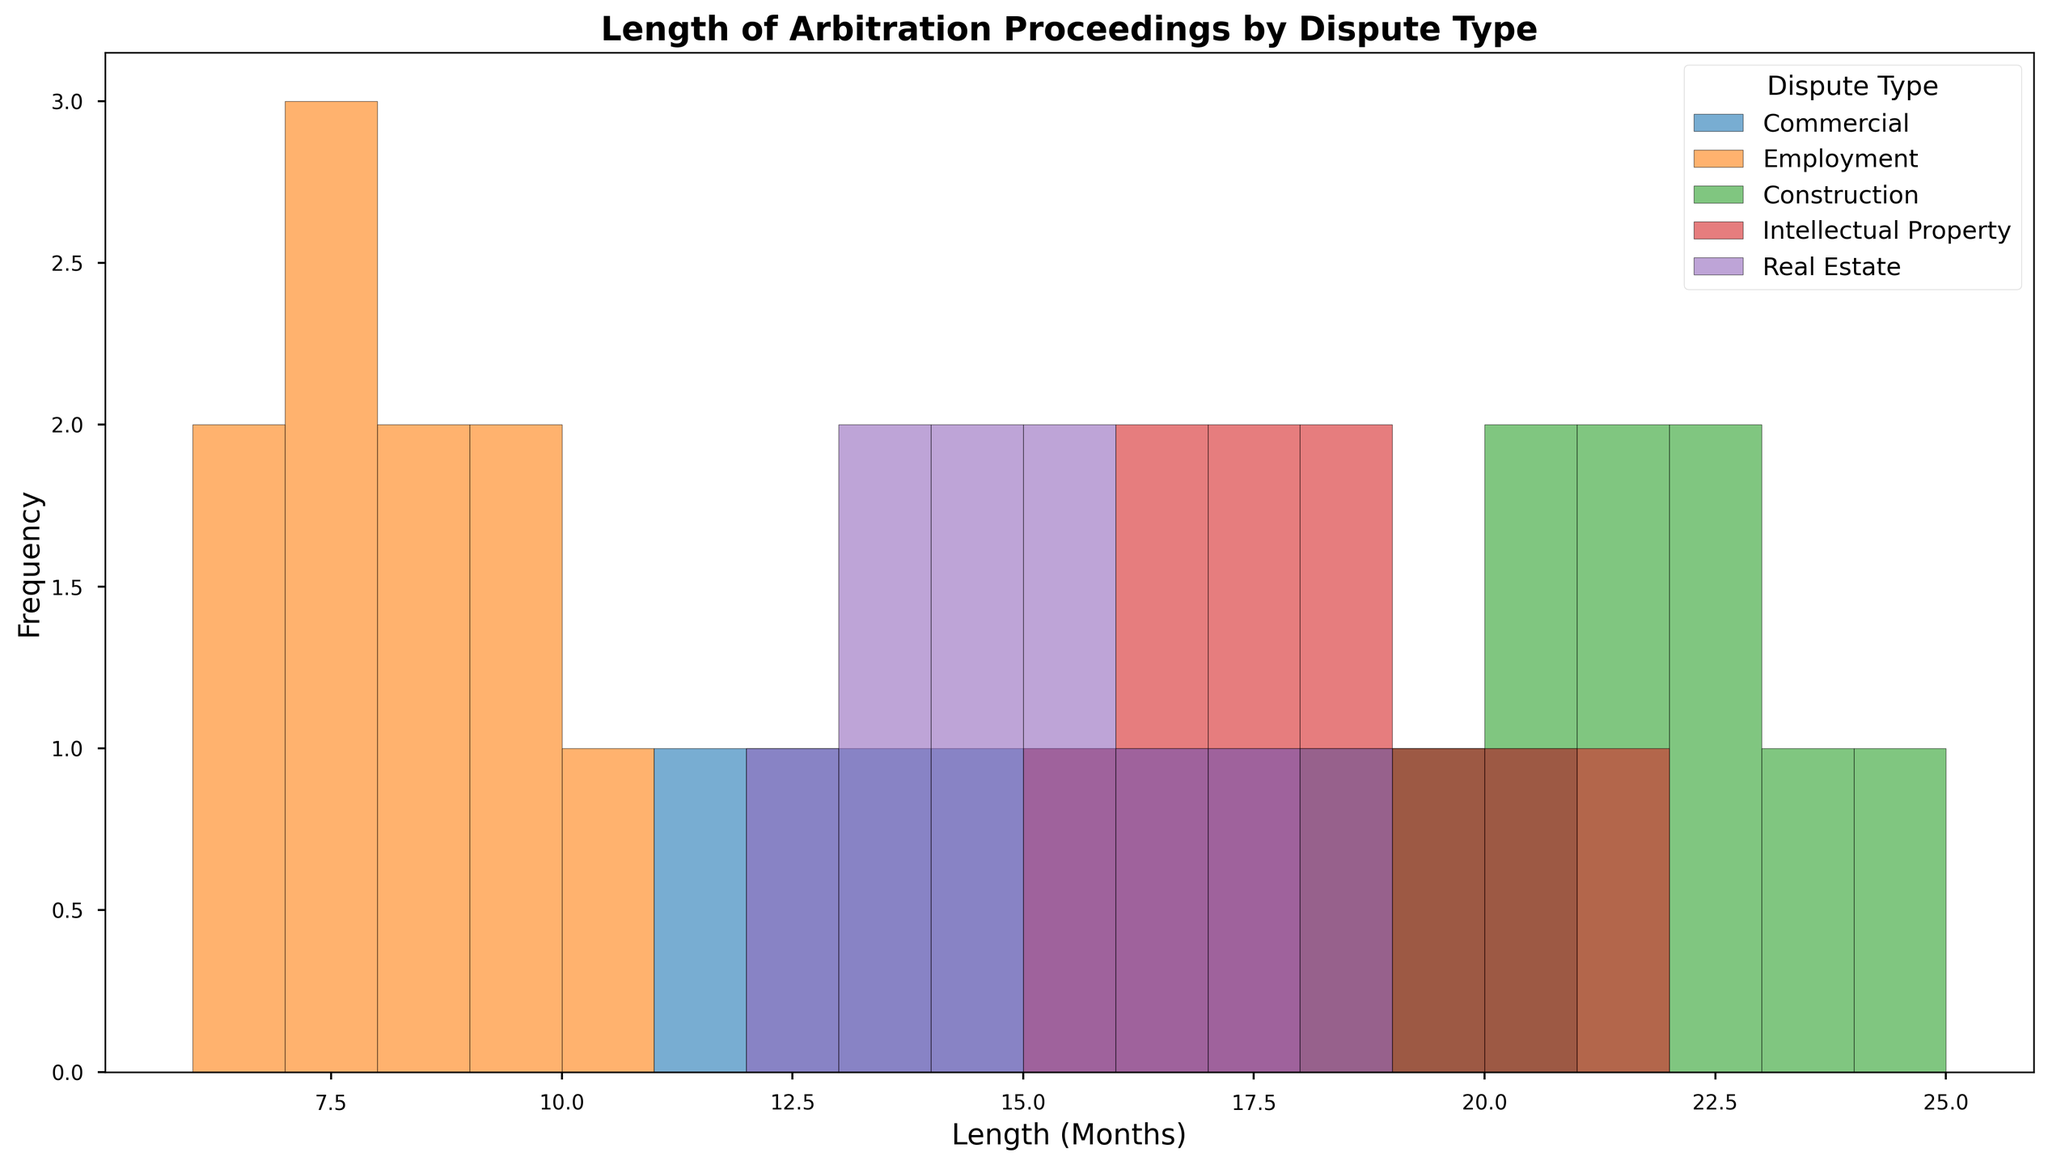Which dispute type has the longest average length of arbitration proceedings? To find the dispute type with the longest average length, calculate the average length in months for each dispute type and compare. Adding up and averaging the lengths:
- Commercial: (14+12+15+13+18+17+19+16+20+11)/10 = 15.5
- Employment: (6+7+8+7+9+6+10+8+9+7)/10 = 7.7
- Construction: (20+22+18+21+23+19+22+24+20+21)/10 = 21
- Intellectual Property: (16+18+17+15+19+16+20+21+18+17)/10 = 17.7
- Real Estate: (14+16+15+13+17+18+14+13+15+12)/10 = 14.7
Construction has the longest average length of 21 months.
Answer: Construction Which dispute type has the highest peak frequency in the histogram? Looking at the heights of the bars in the histogram, identify the dispute type with the tallest bar. The tallest bar is for Construction, around 20 months.
Answer: Construction What's the modal (most frequently occurring) length of arbitration proceedings for Employment disputes? The histogram shows the frequency distribution. For Employment, the tallest bar corresponds to a length of 7 months.
Answer: 7 How does the distribution frequency of Commercial disputes compare to Real Estate disputes? The distribution frequency of Commercial disputes has a higher and wider spread in the 11-20 month range compared to Real Estate disputes which are confined more narrowly between 12-18 months.
Answer: Commercial has a wider spread What is the range of arbitration lengths for Intellectual Property disputes? From the Intellectual Property distribution, the minimum value is 15 months and the maximum is 21 months. Calculate the range: 21 - 15 = 6 months.
Answer: 6 How many dispute types have their frequency peak at 20 months or above? Look at the histograms and note the dispute types with their highest bars at 20 months or higher. Construction and Intellectual Property dispute types peak at 20 or above.
Answer: 2 Compare the lengths of arbitration proceedings between Employment and Real Estate disputes. Which has more concentrated periods? Employment disputes are more concentrated around 6-10 months with peaks at 6 and 7, while Real Estate disputes spread out from 12-18 months with a less sharp peak. Employment is more concentrated.
Answer: Employment Which two dispute types have the closest average lengths of arbitration proceedings? Calculate and compare the average lengths from the data:
- Commercial: 15.5
- Employment: 7.7
- Construction: 21
- Intellectual Property: 17.7
- Real Estate: 14.7
The closest averages are Commercial (15.5) and Real Estate (14.7) with a difference of 0.8 months.
Answer: Commercial and Real Estate 